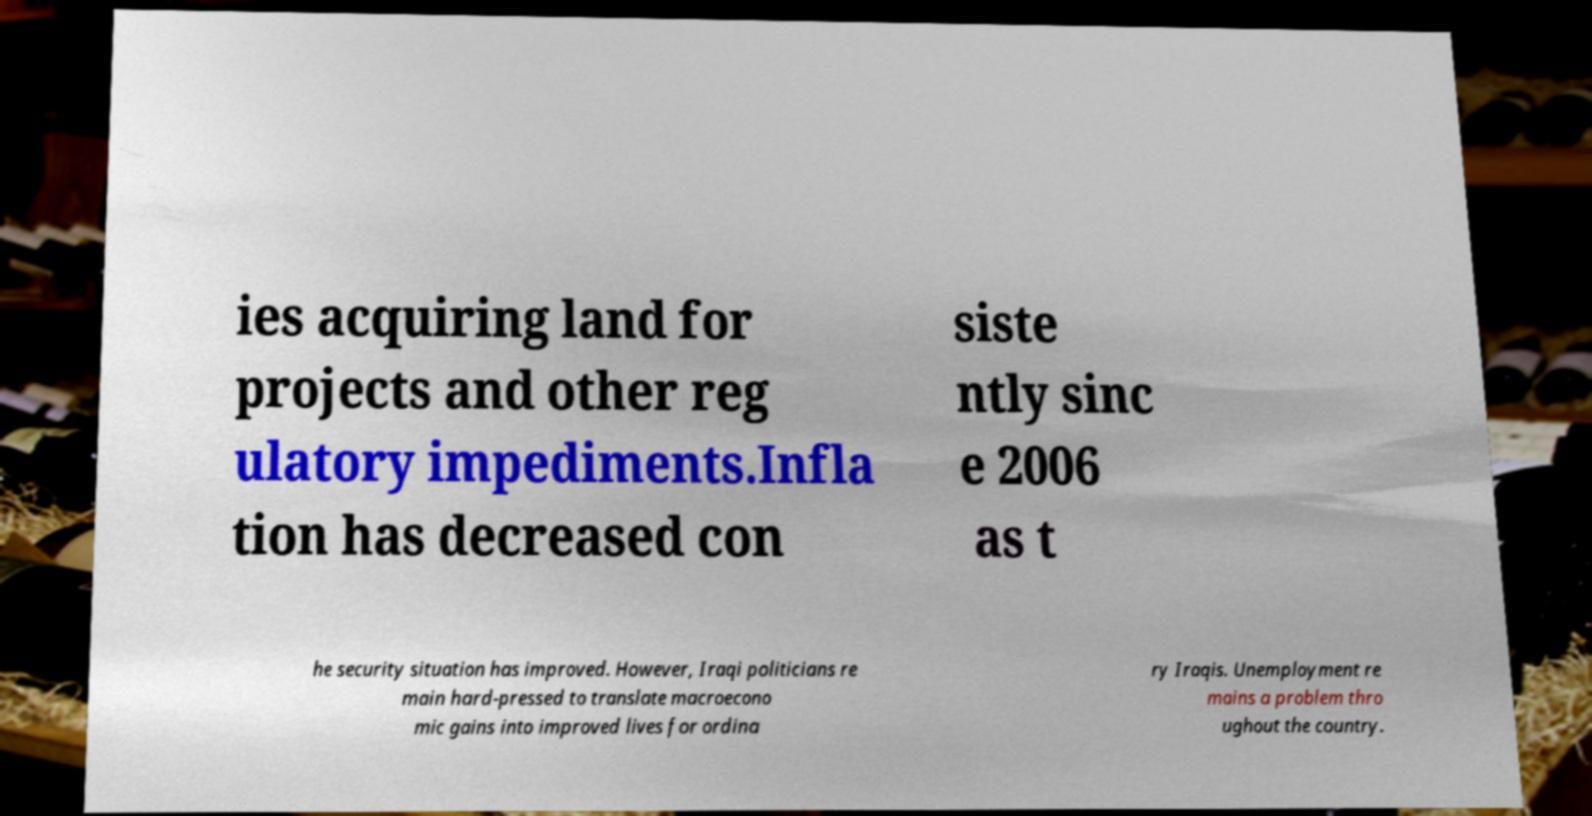Could you extract and type out the text from this image? ies acquiring land for projects and other reg ulatory impediments.Infla tion has decreased con siste ntly sinc e 2006 as t he security situation has improved. However, Iraqi politicians re main hard-pressed to translate macroecono mic gains into improved lives for ordina ry Iraqis. Unemployment re mains a problem thro ughout the country. 